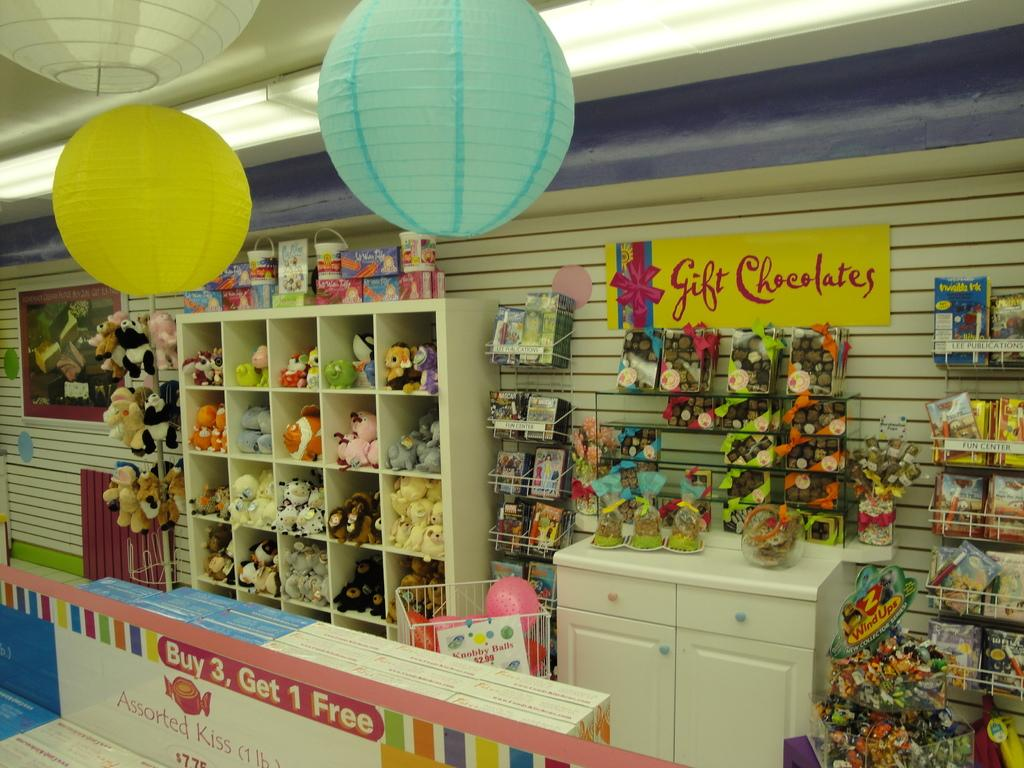<image>
Render a clear and concise summary of the photo. A gift chocolates banner is on the back wall of this store with various toys on display. 